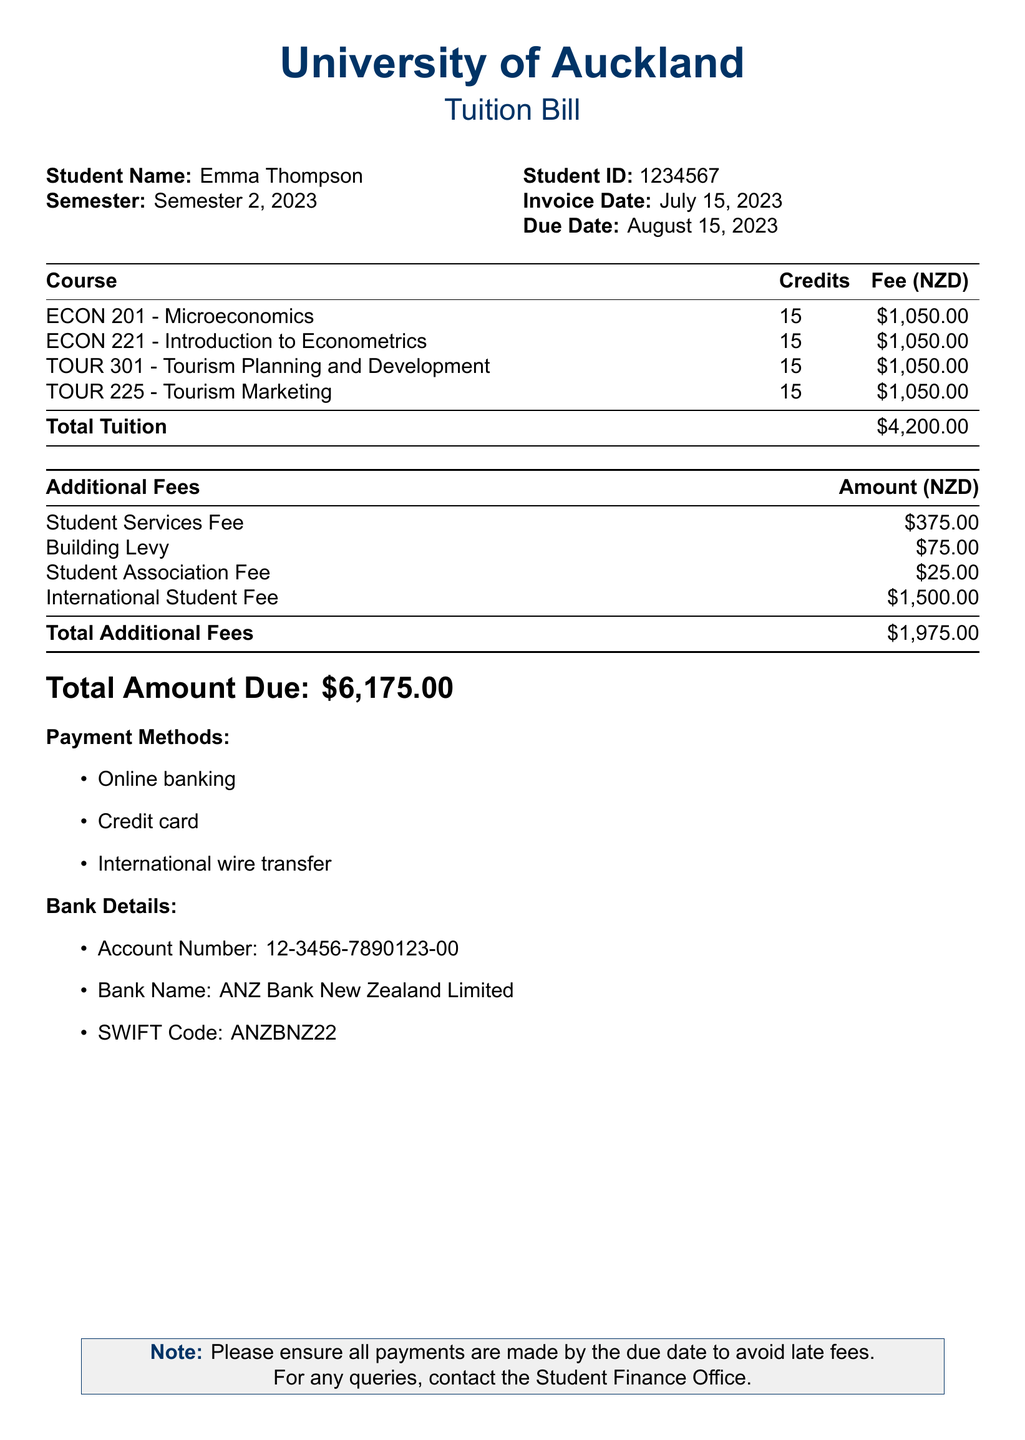What is the student name? The student name is explicitly stated in the document as Emma Thompson.
Answer: Emma Thompson What is the total tuition fee? The total tuition fee is calculated based on all course fees listed, which sums up to $4,200.00.
Answer: $4,200.00 What is the due date for the payment? The due date is mentioned in the document as August 15, 2023.
Answer: August 15, 2023 How many courses is the student enrolled in? The document lists four courses that the student is enrolled in.
Answer: Four What is the amount for the International Student Fee? The document specifies the International Student Fee as $1,500.00.
Answer: $1,500.00 What is the total amount due? The total amount due is the sum of the total tuition and total additional fees, which is $6,175.00.
Answer: $6,175.00 What is the student's ID? The student ID is provided in the document as 1234567.
Answer: 1234567 What method of payments are accepted? The document lists three accepted payment methods: online banking, credit card, and international wire transfer.
Answer: Online banking, credit card, international wire transfer What is the Building Levy amount? The Building Levy is specifically listed in the document as $75.00.
Answer: $75.00 